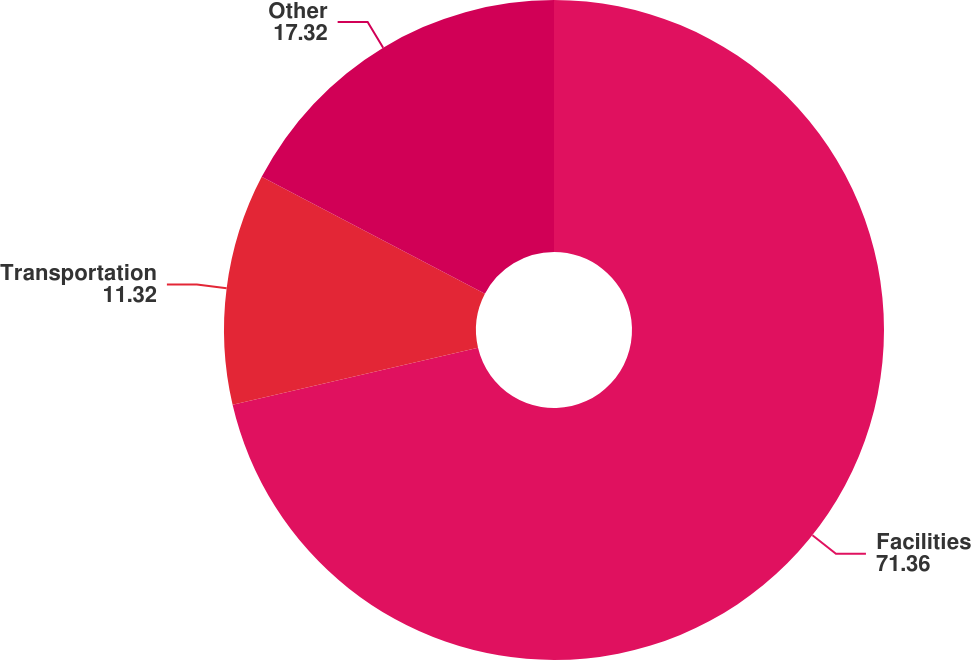Convert chart. <chart><loc_0><loc_0><loc_500><loc_500><pie_chart><fcel>Facilities<fcel>Transportation<fcel>Other<nl><fcel>71.36%<fcel>11.32%<fcel>17.32%<nl></chart> 